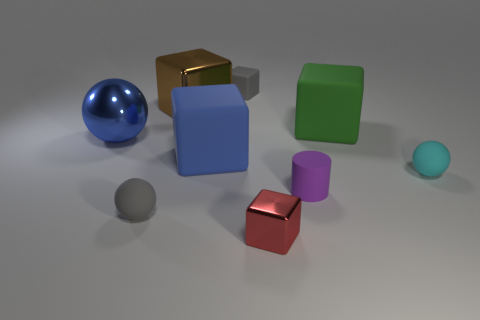What size is the sphere that is on the left side of the tiny cyan matte ball and behind the matte cylinder?
Provide a succinct answer. Large. What shape is the purple matte object?
Ensure brevity in your answer.  Cylinder. Is there a big blue sphere in front of the rubber ball that is to the right of the gray ball?
Ensure brevity in your answer.  No. There is a brown cube that is the same size as the green cube; what is its material?
Keep it short and to the point. Metal. Are there any green shiny spheres that have the same size as the purple object?
Keep it short and to the point. No. What material is the small ball on the left side of the large green cube?
Ensure brevity in your answer.  Rubber. Is the large blue thing in front of the shiny sphere made of the same material as the purple cylinder?
Your answer should be compact. Yes. What shape is the matte thing that is the same size as the blue matte block?
Your response must be concise. Cube. How many matte cubes are the same color as the large sphere?
Ensure brevity in your answer.  1. Are there fewer blue spheres in front of the tiny cyan thing than small rubber cylinders behind the purple object?
Make the answer very short. No. 